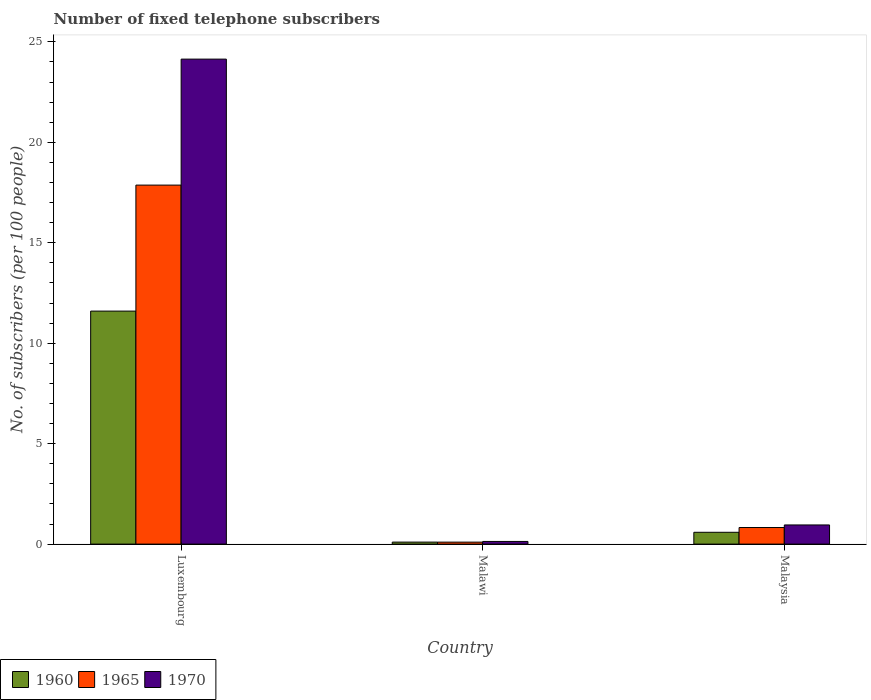How many different coloured bars are there?
Offer a very short reply. 3. Are the number of bars per tick equal to the number of legend labels?
Give a very brief answer. Yes. Are the number of bars on each tick of the X-axis equal?
Provide a succinct answer. Yes. How many bars are there on the 1st tick from the left?
Ensure brevity in your answer.  3. How many bars are there on the 2nd tick from the right?
Ensure brevity in your answer.  3. What is the label of the 3rd group of bars from the left?
Offer a very short reply. Malaysia. What is the number of fixed telephone subscribers in 1965 in Malawi?
Provide a succinct answer. 0.1. Across all countries, what is the maximum number of fixed telephone subscribers in 1965?
Keep it short and to the point. 17.87. Across all countries, what is the minimum number of fixed telephone subscribers in 1965?
Provide a succinct answer. 0.1. In which country was the number of fixed telephone subscribers in 1970 maximum?
Give a very brief answer. Luxembourg. In which country was the number of fixed telephone subscribers in 1960 minimum?
Offer a very short reply. Malawi. What is the total number of fixed telephone subscribers in 1960 in the graph?
Give a very brief answer. 12.29. What is the difference between the number of fixed telephone subscribers in 1960 in Malawi and that in Malaysia?
Offer a terse response. -0.49. What is the difference between the number of fixed telephone subscribers in 1965 in Luxembourg and the number of fixed telephone subscribers in 1970 in Malaysia?
Provide a short and direct response. 16.92. What is the average number of fixed telephone subscribers in 1965 per country?
Your answer should be very brief. 6.26. What is the difference between the number of fixed telephone subscribers of/in 1960 and number of fixed telephone subscribers of/in 1970 in Malaysia?
Your response must be concise. -0.36. In how many countries, is the number of fixed telephone subscribers in 1960 greater than 9?
Provide a short and direct response. 1. What is the ratio of the number of fixed telephone subscribers in 1960 in Luxembourg to that in Malaysia?
Ensure brevity in your answer.  19.71. Is the number of fixed telephone subscribers in 1960 in Luxembourg less than that in Malawi?
Give a very brief answer. No. What is the difference between the highest and the second highest number of fixed telephone subscribers in 1960?
Provide a short and direct response. -11.01. What is the difference between the highest and the lowest number of fixed telephone subscribers in 1970?
Make the answer very short. 24.01. In how many countries, is the number of fixed telephone subscribers in 1960 greater than the average number of fixed telephone subscribers in 1960 taken over all countries?
Make the answer very short. 1. Is the sum of the number of fixed telephone subscribers in 1970 in Malawi and Malaysia greater than the maximum number of fixed telephone subscribers in 1960 across all countries?
Your answer should be compact. No. What does the 2nd bar from the left in Malaysia represents?
Give a very brief answer. 1965. What does the 2nd bar from the right in Malaysia represents?
Provide a succinct answer. 1965. Is it the case that in every country, the sum of the number of fixed telephone subscribers in 1965 and number of fixed telephone subscribers in 1970 is greater than the number of fixed telephone subscribers in 1960?
Offer a very short reply. Yes. How many bars are there?
Ensure brevity in your answer.  9. Are all the bars in the graph horizontal?
Your answer should be compact. No. What is the difference between two consecutive major ticks on the Y-axis?
Give a very brief answer. 5. Are the values on the major ticks of Y-axis written in scientific E-notation?
Offer a very short reply. No. Does the graph contain grids?
Keep it short and to the point. No. Where does the legend appear in the graph?
Give a very brief answer. Bottom left. How many legend labels are there?
Offer a very short reply. 3. What is the title of the graph?
Your response must be concise. Number of fixed telephone subscribers. What is the label or title of the Y-axis?
Keep it short and to the point. No. of subscribers (per 100 people). What is the No. of subscribers (per 100 people) of 1960 in Luxembourg?
Provide a short and direct response. 11.6. What is the No. of subscribers (per 100 people) of 1965 in Luxembourg?
Provide a short and direct response. 17.87. What is the No. of subscribers (per 100 people) in 1970 in Luxembourg?
Your answer should be very brief. 24.14. What is the No. of subscribers (per 100 people) in 1960 in Malawi?
Your answer should be compact. 0.1. What is the No. of subscribers (per 100 people) in 1965 in Malawi?
Provide a short and direct response. 0.1. What is the No. of subscribers (per 100 people) of 1970 in Malawi?
Offer a very short reply. 0.13. What is the No. of subscribers (per 100 people) in 1960 in Malaysia?
Your answer should be compact. 0.59. What is the No. of subscribers (per 100 people) of 1965 in Malaysia?
Your answer should be compact. 0.83. What is the No. of subscribers (per 100 people) of 1970 in Malaysia?
Provide a short and direct response. 0.95. Across all countries, what is the maximum No. of subscribers (per 100 people) of 1960?
Your answer should be very brief. 11.6. Across all countries, what is the maximum No. of subscribers (per 100 people) of 1965?
Offer a very short reply. 17.87. Across all countries, what is the maximum No. of subscribers (per 100 people) of 1970?
Your answer should be very brief. 24.14. Across all countries, what is the minimum No. of subscribers (per 100 people) in 1960?
Provide a short and direct response. 0.1. Across all countries, what is the minimum No. of subscribers (per 100 people) of 1965?
Keep it short and to the point. 0.1. Across all countries, what is the minimum No. of subscribers (per 100 people) of 1970?
Ensure brevity in your answer.  0.13. What is the total No. of subscribers (per 100 people) in 1960 in the graph?
Offer a very short reply. 12.29. What is the total No. of subscribers (per 100 people) of 1965 in the graph?
Give a very brief answer. 18.79. What is the total No. of subscribers (per 100 people) of 1970 in the graph?
Ensure brevity in your answer.  25.23. What is the difference between the No. of subscribers (per 100 people) of 1960 in Luxembourg and that in Malawi?
Provide a succinct answer. 11.5. What is the difference between the No. of subscribers (per 100 people) in 1965 in Luxembourg and that in Malawi?
Provide a succinct answer. 17.77. What is the difference between the No. of subscribers (per 100 people) of 1970 in Luxembourg and that in Malawi?
Your response must be concise. 24.01. What is the difference between the No. of subscribers (per 100 people) in 1960 in Luxembourg and that in Malaysia?
Give a very brief answer. 11.01. What is the difference between the No. of subscribers (per 100 people) of 1965 in Luxembourg and that in Malaysia?
Your response must be concise. 17.04. What is the difference between the No. of subscribers (per 100 people) of 1970 in Luxembourg and that in Malaysia?
Provide a succinct answer. 23.19. What is the difference between the No. of subscribers (per 100 people) of 1960 in Malawi and that in Malaysia?
Your response must be concise. -0.49. What is the difference between the No. of subscribers (per 100 people) of 1965 in Malawi and that in Malaysia?
Keep it short and to the point. -0.73. What is the difference between the No. of subscribers (per 100 people) in 1970 in Malawi and that in Malaysia?
Your answer should be very brief. -0.82. What is the difference between the No. of subscribers (per 100 people) of 1960 in Luxembourg and the No. of subscribers (per 100 people) of 1965 in Malawi?
Give a very brief answer. 11.5. What is the difference between the No. of subscribers (per 100 people) of 1960 in Luxembourg and the No. of subscribers (per 100 people) of 1970 in Malawi?
Offer a very short reply. 11.47. What is the difference between the No. of subscribers (per 100 people) of 1965 in Luxembourg and the No. of subscribers (per 100 people) of 1970 in Malawi?
Make the answer very short. 17.74. What is the difference between the No. of subscribers (per 100 people) of 1960 in Luxembourg and the No. of subscribers (per 100 people) of 1965 in Malaysia?
Give a very brief answer. 10.77. What is the difference between the No. of subscribers (per 100 people) of 1960 in Luxembourg and the No. of subscribers (per 100 people) of 1970 in Malaysia?
Offer a very short reply. 10.64. What is the difference between the No. of subscribers (per 100 people) in 1965 in Luxembourg and the No. of subscribers (per 100 people) in 1970 in Malaysia?
Provide a succinct answer. 16.92. What is the difference between the No. of subscribers (per 100 people) in 1960 in Malawi and the No. of subscribers (per 100 people) in 1965 in Malaysia?
Make the answer very short. -0.73. What is the difference between the No. of subscribers (per 100 people) in 1960 in Malawi and the No. of subscribers (per 100 people) in 1970 in Malaysia?
Make the answer very short. -0.85. What is the difference between the No. of subscribers (per 100 people) of 1965 in Malawi and the No. of subscribers (per 100 people) of 1970 in Malaysia?
Provide a succinct answer. -0.86. What is the average No. of subscribers (per 100 people) of 1960 per country?
Offer a very short reply. 4.1. What is the average No. of subscribers (per 100 people) of 1965 per country?
Your answer should be compact. 6.26. What is the average No. of subscribers (per 100 people) of 1970 per country?
Ensure brevity in your answer.  8.41. What is the difference between the No. of subscribers (per 100 people) in 1960 and No. of subscribers (per 100 people) in 1965 in Luxembourg?
Offer a very short reply. -6.27. What is the difference between the No. of subscribers (per 100 people) in 1960 and No. of subscribers (per 100 people) in 1970 in Luxembourg?
Your answer should be compact. -12.54. What is the difference between the No. of subscribers (per 100 people) of 1965 and No. of subscribers (per 100 people) of 1970 in Luxembourg?
Offer a very short reply. -6.27. What is the difference between the No. of subscribers (per 100 people) of 1960 and No. of subscribers (per 100 people) of 1965 in Malawi?
Keep it short and to the point. 0. What is the difference between the No. of subscribers (per 100 people) in 1960 and No. of subscribers (per 100 people) in 1970 in Malawi?
Your response must be concise. -0.03. What is the difference between the No. of subscribers (per 100 people) of 1965 and No. of subscribers (per 100 people) of 1970 in Malawi?
Make the answer very short. -0.03. What is the difference between the No. of subscribers (per 100 people) of 1960 and No. of subscribers (per 100 people) of 1965 in Malaysia?
Make the answer very short. -0.24. What is the difference between the No. of subscribers (per 100 people) in 1960 and No. of subscribers (per 100 people) in 1970 in Malaysia?
Your answer should be very brief. -0.36. What is the difference between the No. of subscribers (per 100 people) of 1965 and No. of subscribers (per 100 people) of 1970 in Malaysia?
Ensure brevity in your answer.  -0.13. What is the ratio of the No. of subscribers (per 100 people) in 1960 in Luxembourg to that in Malawi?
Ensure brevity in your answer.  116.81. What is the ratio of the No. of subscribers (per 100 people) of 1965 in Luxembourg to that in Malawi?
Give a very brief answer. 182.09. What is the ratio of the No. of subscribers (per 100 people) in 1970 in Luxembourg to that in Malawi?
Your answer should be very brief. 182.25. What is the ratio of the No. of subscribers (per 100 people) in 1960 in Luxembourg to that in Malaysia?
Provide a succinct answer. 19.71. What is the ratio of the No. of subscribers (per 100 people) in 1965 in Luxembourg to that in Malaysia?
Make the answer very short. 21.65. What is the ratio of the No. of subscribers (per 100 people) in 1970 in Luxembourg to that in Malaysia?
Provide a short and direct response. 25.32. What is the ratio of the No. of subscribers (per 100 people) of 1960 in Malawi to that in Malaysia?
Provide a short and direct response. 0.17. What is the ratio of the No. of subscribers (per 100 people) in 1965 in Malawi to that in Malaysia?
Keep it short and to the point. 0.12. What is the ratio of the No. of subscribers (per 100 people) of 1970 in Malawi to that in Malaysia?
Offer a terse response. 0.14. What is the difference between the highest and the second highest No. of subscribers (per 100 people) of 1960?
Ensure brevity in your answer.  11.01. What is the difference between the highest and the second highest No. of subscribers (per 100 people) in 1965?
Provide a short and direct response. 17.04. What is the difference between the highest and the second highest No. of subscribers (per 100 people) of 1970?
Provide a succinct answer. 23.19. What is the difference between the highest and the lowest No. of subscribers (per 100 people) of 1960?
Provide a short and direct response. 11.5. What is the difference between the highest and the lowest No. of subscribers (per 100 people) in 1965?
Your answer should be compact. 17.77. What is the difference between the highest and the lowest No. of subscribers (per 100 people) of 1970?
Your response must be concise. 24.01. 